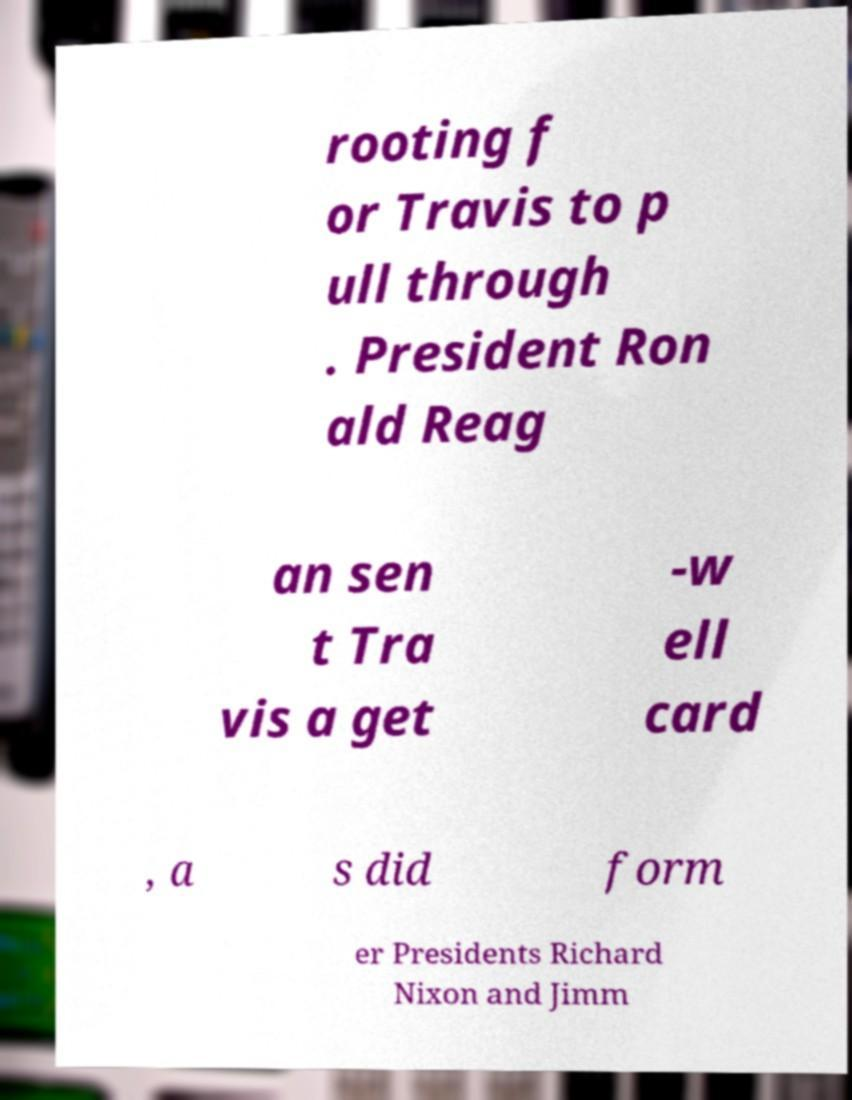What messages or text are displayed in this image? I need them in a readable, typed format. rooting f or Travis to p ull through . President Ron ald Reag an sen t Tra vis a get -w ell card , a s did form er Presidents Richard Nixon and Jimm 